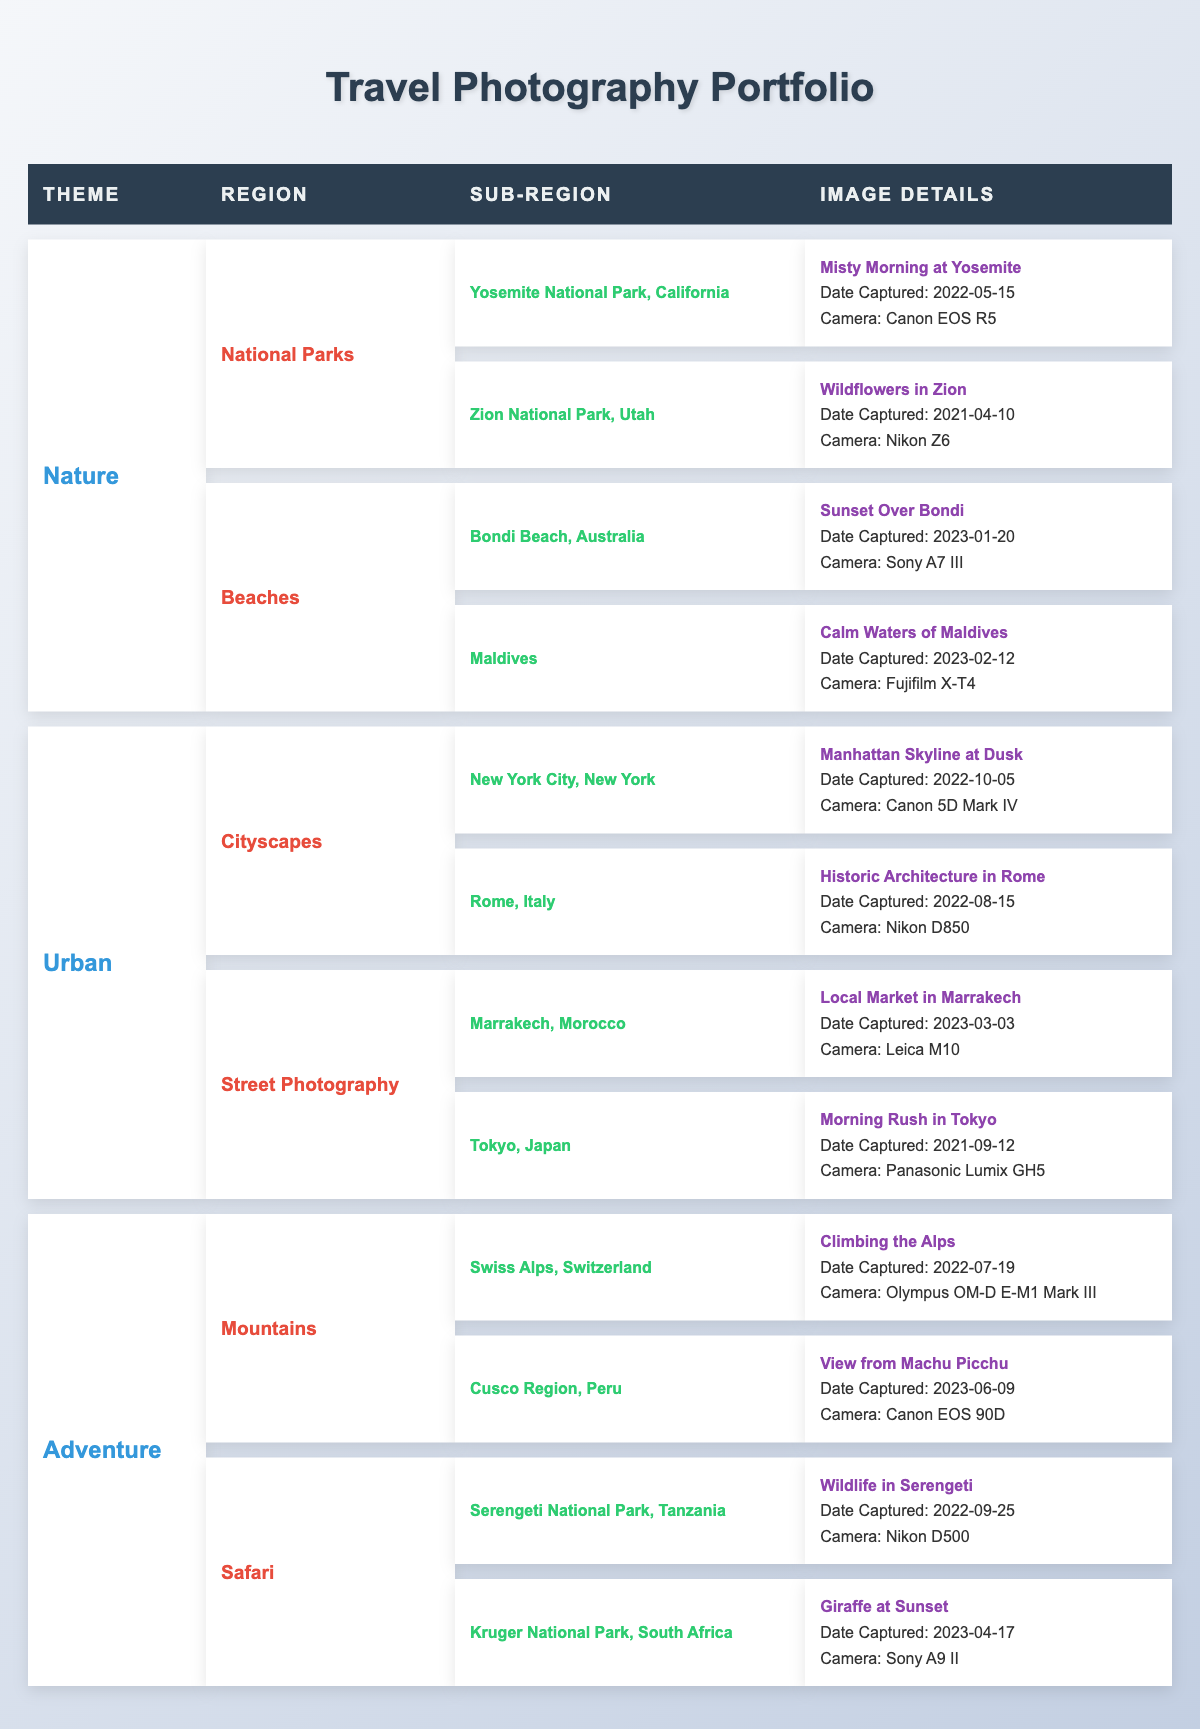What is the title of the image captured in Yosemite National Park? The table lists "Misty Morning at Yosemite" as the title of the image located under the sub-region of Yosemite National Park, California within the Nature theme.
Answer: Misty Morning at Yosemite How many images feature beaches in the portfolio? There are two images under the Beaches region: "Sunset Over Bondi" and "Calm Waters of Maldives."
Answer: 2 Which camera was used to capture the image "Wildflowers in Zion"? The table specifies that "Wildflowers in Zion" was captured using the Nikon Z6 camera, as stated in the image details for Zion National Park in the Nature theme.
Answer: Nikon Z6 Is there an image captured in Rome? Yes, the table includes "Historic Architecture in Rome" as an image under the Cityscapes region within the Urban theme, confirming that there's one image from Rome.
Answer: Yes What is the geographical area for the image titled "Giraffe at Sunset"? The table indicates that "Giraffe at Sunset" was captured in Kruger National Park, South Africa, which is listed under the Safari region within the Adventure theme.
Answer: Kruger National Park, South Africa How many different themes are represented in the portfolio? The portfolio consists of three main themes: Nature, Urban, and Adventure, as listed in the table, so the total count of themes is three.
Answer: 3 Which region contains the most images in the portfolio? The Nature theme has four images (two in National Parks and two in Beaches), while both Urban and Adventure themes have four images each. Therefore, they all have an equal maximum of four images.
Answer: All have an equal maximum of 4 images How many unique locations are shown in the Adventure theme? In the Adventure theme, there are three unique locations listed under Mountains (Swiss Alps, Peru) and Safari (Tanzania and South Africa), leading to a total of four unique locations.
Answer: 4 What is the date captured for "Morning Rush in Tokyo"? The table clearly states that "Morning Rush in Tokyo" was captured on 2021-09-12 according to the Image Details section under the Street Photography region in the Urban theme.
Answer: 2021-09-12 